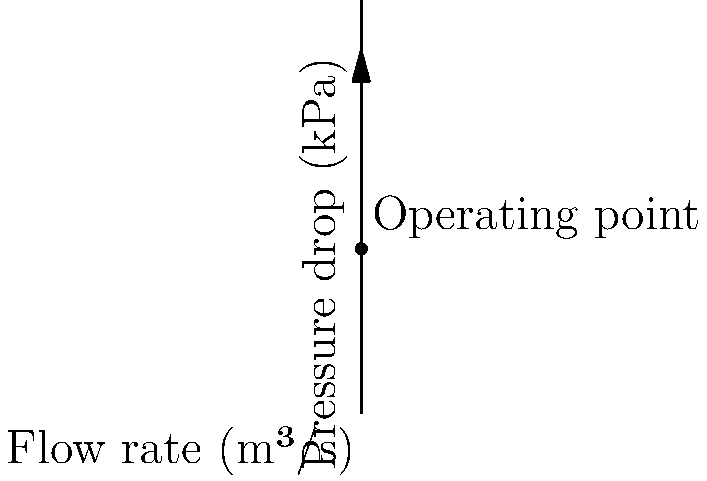A cylindrical filter in a biofuel purification system has a diameter of 0.2 m and a length of 0.5 m. The filter medium has a permeability of $1.2 \times 10^{-10}$ m² and a thickness of 5 mm. The biofuel has a viscosity of 0.005 Pa·s. Using the provided pressure drop vs. flow rate curve, determine the pressure drop across the filter when the flow rate is 0.03 m³/s. How does this compare to the theoretical pressure drop calculated using Darcy's law? To solve this problem, we'll follow these steps:

1) Read the pressure drop from the graph:
   At a flow rate of 0.03 m³/s, the pressure drop is approximately 32 kPa.

2) Calculate the theoretical pressure drop using Darcy's law:
   $$\Delta P = \frac{\mu L Q}{k A}$$
   where:
   $\Delta P$ = pressure drop (Pa)
   $\mu$ = fluid viscosity (Pa·s)
   $L$ = filter thickness (m)
   $Q$ = volumetric flow rate (m³/s)
   $k$ = permeability (m²)
   $A$ = filter area (m²)

3) Calculate the filter area:
   $$A = \pi r^2 = \pi (0.1 \text{ m})^2 = 0.0314 \text{ m}^2$$

4) Apply Darcy's law:
   $$\Delta P = \frac{(0.005 \text{ Pa·s})(0.005 \text{ m})(0.03 \text{ m}³/s)}{(1.2 \times 10^{-10} \text{ m}²)(0.0314 \text{ m}^2)}$$
   $$\Delta P = 39,808 \text{ Pa} = 39.8 \text{ kPa}$$

5) Compare the results:
   Graphical result: 32 kPa
   Theoretical result: 39.8 kPa

The difference is about 24.4%. This discrepancy could be due to factors not accounted for in Darcy's law, such as non-linear effects at higher flow rates, filter compressibility, or variations in permeability across the filter medium.
Answer: Graphical: 32 kPa; Theoretical: 39.8 kPa; 24.4% difference 